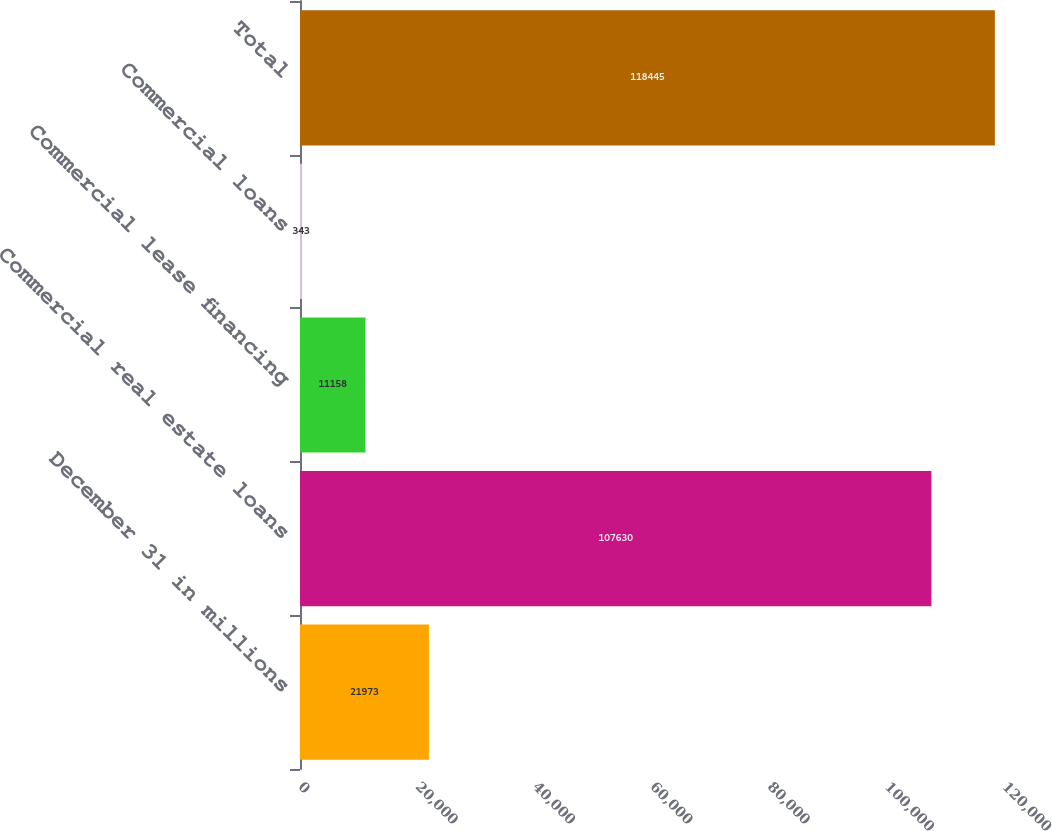<chart> <loc_0><loc_0><loc_500><loc_500><bar_chart><fcel>December 31 in millions<fcel>Commercial real estate loans<fcel>Commercial lease financing<fcel>Commercial loans<fcel>Total<nl><fcel>21973<fcel>107630<fcel>11158<fcel>343<fcel>118445<nl></chart> 